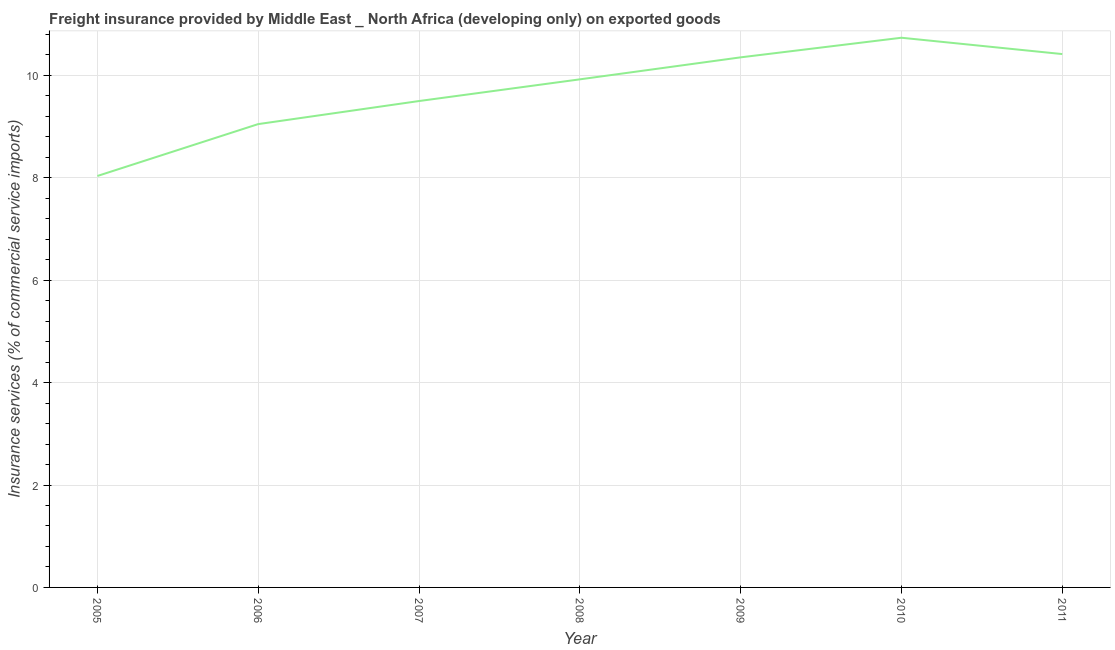What is the freight insurance in 2010?
Provide a short and direct response. 10.74. Across all years, what is the maximum freight insurance?
Give a very brief answer. 10.74. Across all years, what is the minimum freight insurance?
Keep it short and to the point. 8.04. What is the sum of the freight insurance?
Make the answer very short. 68.02. What is the difference between the freight insurance in 2007 and 2008?
Keep it short and to the point. -0.42. What is the average freight insurance per year?
Make the answer very short. 9.72. What is the median freight insurance?
Provide a succinct answer. 9.92. In how many years, is the freight insurance greater than 10 %?
Provide a short and direct response. 3. Do a majority of the years between 2011 and 2007 (inclusive) have freight insurance greater than 4.8 %?
Give a very brief answer. Yes. What is the ratio of the freight insurance in 2010 to that in 2011?
Provide a short and direct response. 1.03. Is the difference between the freight insurance in 2008 and 2009 greater than the difference between any two years?
Provide a short and direct response. No. What is the difference between the highest and the second highest freight insurance?
Give a very brief answer. 0.32. Is the sum of the freight insurance in 2006 and 2010 greater than the maximum freight insurance across all years?
Provide a succinct answer. Yes. What is the difference between the highest and the lowest freight insurance?
Offer a very short reply. 2.7. In how many years, is the freight insurance greater than the average freight insurance taken over all years?
Offer a very short reply. 4. How many lines are there?
Your response must be concise. 1. What is the difference between two consecutive major ticks on the Y-axis?
Offer a very short reply. 2. What is the title of the graph?
Make the answer very short. Freight insurance provided by Middle East _ North Africa (developing only) on exported goods . What is the label or title of the X-axis?
Ensure brevity in your answer.  Year. What is the label or title of the Y-axis?
Provide a succinct answer. Insurance services (% of commercial service imports). What is the Insurance services (% of commercial service imports) of 2005?
Your answer should be very brief. 8.04. What is the Insurance services (% of commercial service imports) of 2006?
Your response must be concise. 9.05. What is the Insurance services (% of commercial service imports) of 2007?
Offer a terse response. 9.5. What is the Insurance services (% of commercial service imports) of 2008?
Provide a succinct answer. 9.92. What is the Insurance services (% of commercial service imports) of 2009?
Provide a short and direct response. 10.35. What is the Insurance services (% of commercial service imports) in 2010?
Your answer should be very brief. 10.74. What is the Insurance services (% of commercial service imports) in 2011?
Ensure brevity in your answer.  10.42. What is the difference between the Insurance services (% of commercial service imports) in 2005 and 2006?
Provide a short and direct response. -1.01. What is the difference between the Insurance services (% of commercial service imports) in 2005 and 2007?
Offer a terse response. -1.46. What is the difference between the Insurance services (% of commercial service imports) in 2005 and 2008?
Make the answer very short. -1.89. What is the difference between the Insurance services (% of commercial service imports) in 2005 and 2009?
Ensure brevity in your answer.  -2.32. What is the difference between the Insurance services (% of commercial service imports) in 2005 and 2010?
Your response must be concise. -2.7. What is the difference between the Insurance services (% of commercial service imports) in 2005 and 2011?
Provide a succinct answer. -2.38. What is the difference between the Insurance services (% of commercial service imports) in 2006 and 2007?
Offer a terse response. -0.45. What is the difference between the Insurance services (% of commercial service imports) in 2006 and 2008?
Offer a very short reply. -0.87. What is the difference between the Insurance services (% of commercial service imports) in 2006 and 2009?
Keep it short and to the point. -1.3. What is the difference between the Insurance services (% of commercial service imports) in 2006 and 2010?
Keep it short and to the point. -1.69. What is the difference between the Insurance services (% of commercial service imports) in 2006 and 2011?
Provide a short and direct response. -1.37. What is the difference between the Insurance services (% of commercial service imports) in 2007 and 2008?
Offer a very short reply. -0.42. What is the difference between the Insurance services (% of commercial service imports) in 2007 and 2009?
Your response must be concise. -0.85. What is the difference between the Insurance services (% of commercial service imports) in 2007 and 2010?
Your answer should be very brief. -1.24. What is the difference between the Insurance services (% of commercial service imports) in 2007 and 2011?
Your response must be concise. -0.92. What is the difference between the Insurance services (% of commercial service imports) in 2008 and 2009?
Your answer should be compact. -0.43. What is the difference between the Insurance services (% of commercial service imports) in 2008 and 2010?
Offer a very short reply. -0.81. What is the difference between the Insurance services (% of commercial service imports) in 2008 and 2011?
Your answer should be compact. -0.49. What is the difference between the Insurance services (% of commercial service imports) in 2009 and 2010?
Give a very brief answer. -0.38. What is the difference between the Insurance services (% of commercial service imports) in 2009 and 2011?
Your response must be concise. -0.06. What is the difference between the Insurance services (% of commercial service imports) in 2010 and 2011?
Provide a short and direct response. 0.32. What is the ratio of the Insurance services (% of commercial service imports) in 2005 to that in 2006?
Offer a very short reply. 0.89. What is the ratio of the Insurance services (% of commercial service imports) in 2005 to that in 2007?
Provide a succinct answer. 0.85. What is the ratio of the Insurance services (% of commercial service imports) in 2005 to that in 2008?
Provide a short and direct response. 0.81. What is the ratio of the Insurance services (% of commercial service imports) in 2005 to that in 2009?
Provide a succinct answer. 0.78. What is the ratio of the Insurance services (% of commercial service imports) in 2005 to that in 2010?
Give a very brief answer. 0.75. What is the ratio of the Insurance services (% of commercial service imports) in 2005 to that in 2011?
Make the answer very short. 0.77. What is the ratio of the Insurance services (% of commercial service imports) in 2006 to that in 2007?
Keep it short and to the point. 0.95. What is the ratio of the Insurance services (% of commercial service imports) in 2006 to that in 2008?
Keep it short and to the point. 0.91. What is the ratio of the Insurance services (% of commercial service imports) in 2006 to that in 2009?
Your answer should be compact. 0.87. What is the ratio of the Insurance services (% of commercial service imports) in 2006 to that in 2010?
Give a very brief answer. 0.84. What is the ratio of the Insurance services (% of commercial service imports) in 2006 to that in 2011?
Offer a terse response. 0.87. What is the ratio of the Insurance services (% of commercial service imports) in 2007 to that in 2009?
Ensure brevity in your answer.  0.92. What is the ratio of the Insurance services (% of commercial service imports) in 2007 to that in 2010?
Provide a short and direct response. 0.89. What is the ratio of the Insurance services (% of commercial service imports) in 2007 to that in 2011?
Your response must be concise. 0.91. What is the ratio of the Insurance services (% of commercial service imports) in 2008 to that in 2009?
Offer a very short reply. 0.96. What is the ratio of the Insurance services (% of commercial service imports) in 2008 to that in 2010?
Provide a short and direct response. 0.92. What is the ratio of the Insurance services (% of commercial service imports) in 2008 to that in 2011?
Your answer should be very brief. 0.95. What is the ratio of the Insurance services (% of commercial service imports) in 2010 to that in 2011?
Provide a succinct answer. 1.03. 